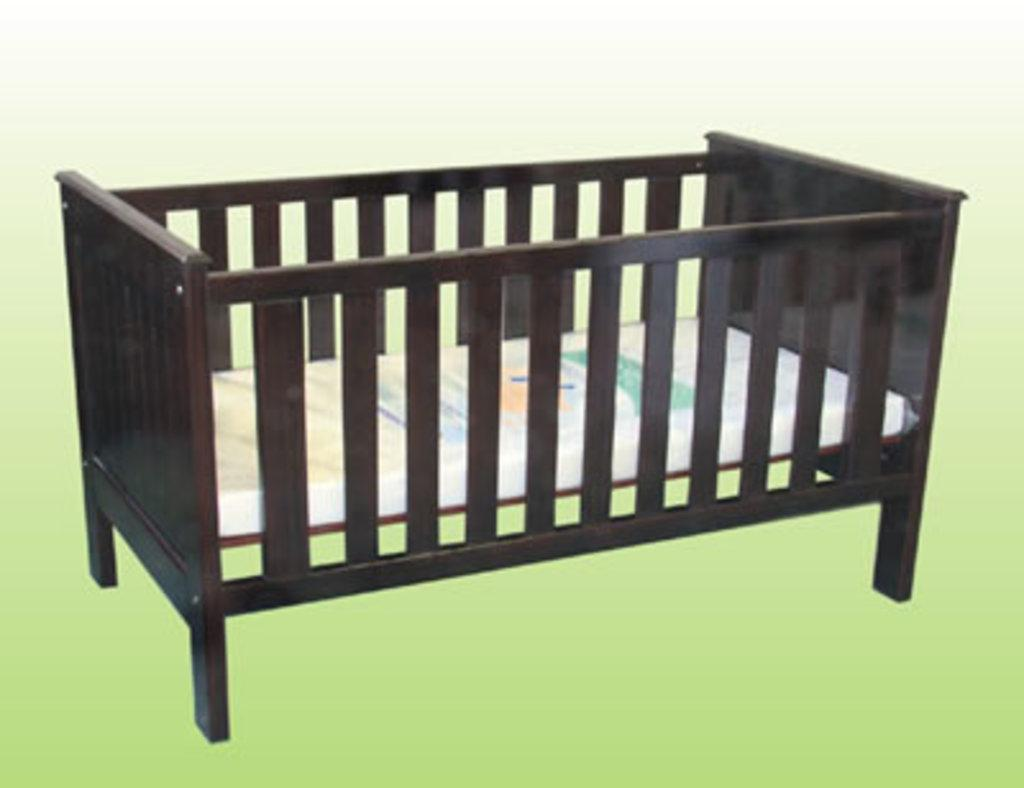What is the main object in the image? There is a cradle in the image. Can you describe the position of the cradle? The cradle is on a surface. Reasoning: Let'g: Let's think step by step in order to produce the conversation. We start by identifying the main subject in the image, which is the cradle. Then, we describe the position of the cradle, which is on a surface. We avoid asking questions that cannot be answered definitively with the information given and ensure that the language is simple and clear. Absurd Question/Answer: Is there an airport visible in the image? No, there is no airport present in the image. What type of branch can be seen supporting the cradle in the image? There is no branch present in the image; the cradle is on a surface. Is there an attack happening in the image? No, there is no attack present in the image. What type of branch can be seen supporting the cradle in the image? There is no branch present in the image; the cradle is on a surface. 